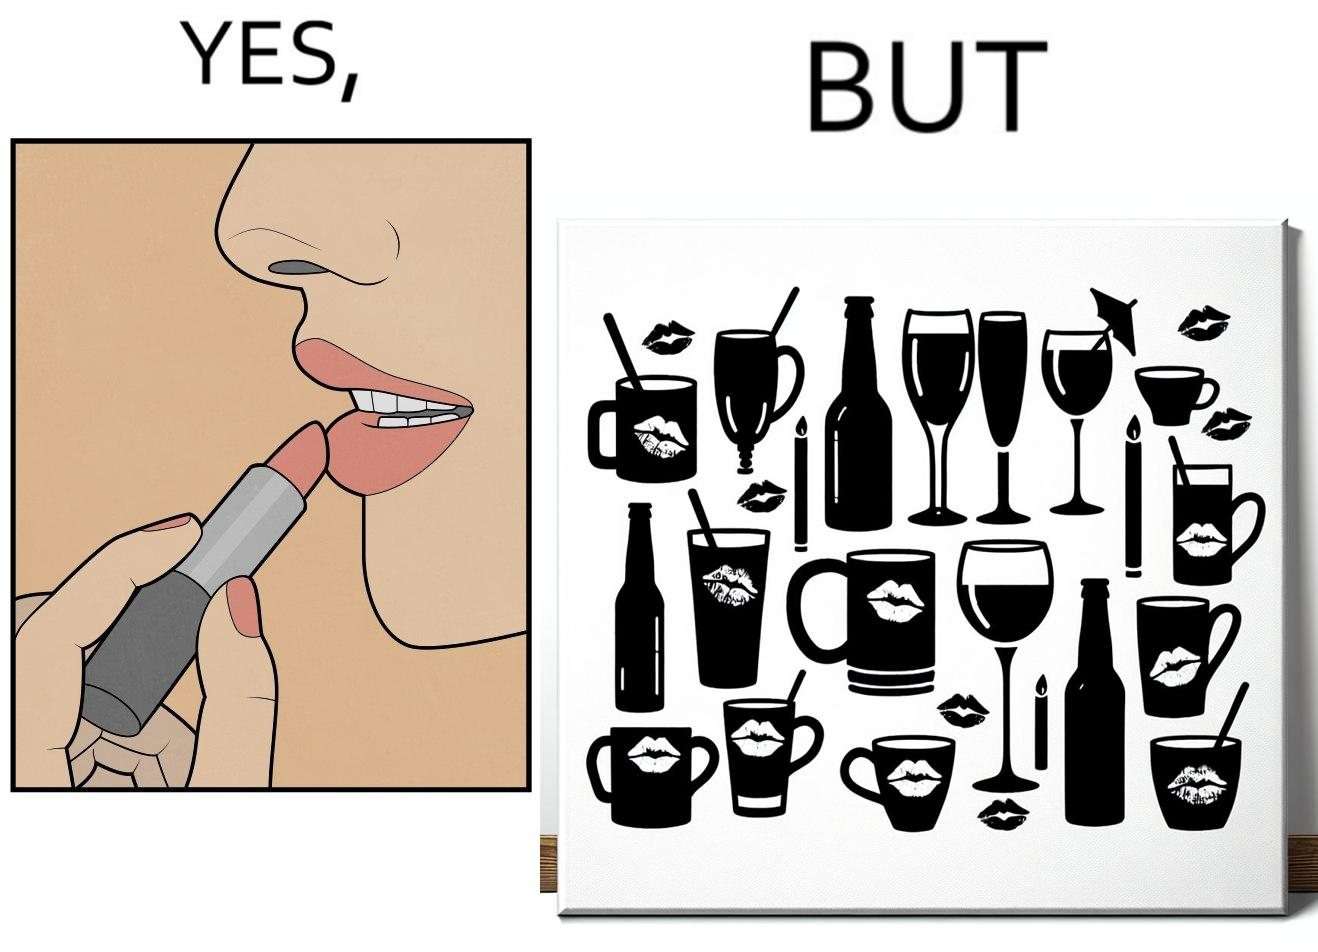Describe the contrast between the left and right parts of this image. In the left part of the image: a person applying lipstick, probably a girl or woman In the right part of the image: lipstick stains on various mugs and glasses 